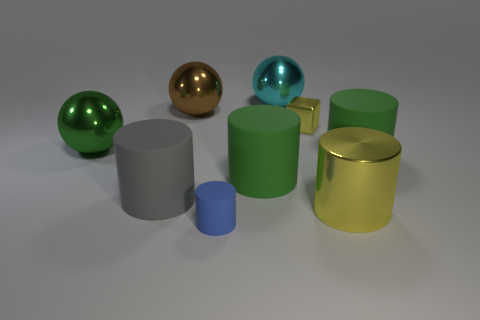Is the number of rubber cylinders left of the cyan ball less than the number of yellow metal blocks in front of the big green ball?
Keep it short and to the point. No. There is a large gray thing; are there any green objects right of it?
Your answer should be compact. Yes. How many things are shiny balls that are in front of the large cyan ball or rubber objects that are in front of the large cyan metallic thing?
Provide a short and direct response. 6. What number of tiny blocks are the same color as the metallic cylinder?
Your answer should be compact. 1. What is the color of the tiny object that is the same shape as the large gray object?
Your answer should be compact. Blue. There is a big object that is both behind the green metal object and left of the blue cylinder; what is its shape?
Provide a short and direct response. Sphere. Is the number of yellow shiny cubes greater than the number of large green objects?
Ensure brevity in your answer.  No. What material is the yellow cylinder?
Offer a very short reply. Metal. Is there any other thing that is the same size as the gray matte cylinder?
Keep it short and to the point. Yes. What size is the yellow shiny thing that is the same shape as the gray object?
Provide a short and direct response. Large. 